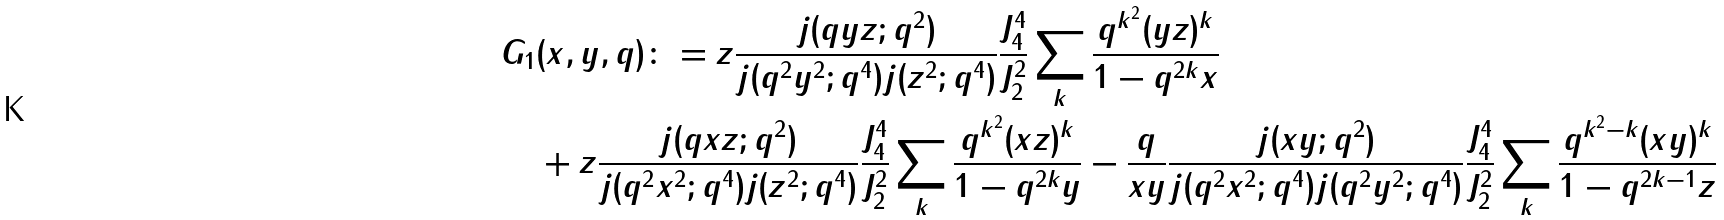<formula> <loc_0><loc_0><loc_500><loc_500>G _ { 1 } & ( x , y , q ) \colon = z \frac { j ( q y z ; q ^ { 2 } ) } { j ( q ^ { 2 } y ^ { 2 } ; q ^ { 4 } ) j ( z ^ { 2 } ; q ^ { 4 } ) } \frac { J _ { 4 } ^ { 4 } } { J _ { 2 } ^ { 2 } } \sum _ { k } \frac { q ^ { k ^ { 2 } } ( y z ) ^ { k } } { 1 - q ^ { 2 k } x } \\ & + z \frac { j ( q x z ; q ^ { 2 } ) } { j ( q ^ { 2 } x ^ { 2 } ; q ^ { 4 } ) j ( z ^ { 2 } ; q ^ { 4 } ) } \frac { J _ { 4 } ^ { 4 } } { J _ { 2 } ^ { 2 } } \sum _ { k } \frac { q ^ { k ^ { 2 } } ( x z ) ^ { k } } { 1 - q ^ { 2 k } y } - \frac { q } { x y } \frac { j ( x y ; q ^ { 2 } ) } { j ( q ^ { 2 } x ^ { 2 } ; q ^ { 4 } ) j ( q ^ { 2 } y ^ { 2 } ; q ^ { 4 } ) } \frac { J _ { 4 } ^ { 4 } } { J _ { 2 } ^ { 2 } } \sum _ { k } \frac { q ^ { k ^ { 2 } - k } ( x y ) ^ { k } } { 1 - q ^ { 2 k - 1 } z }</formula> 